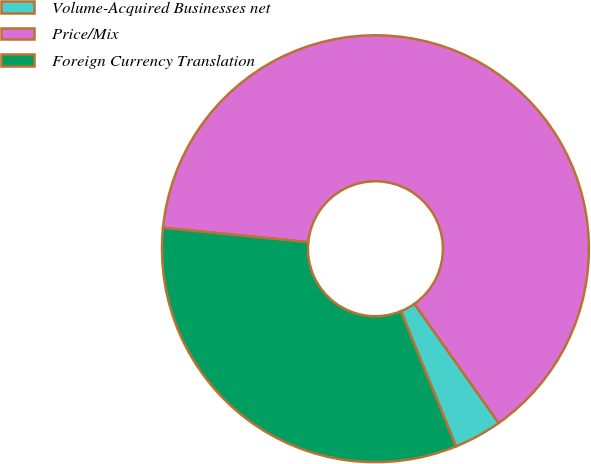Convert chart. <chart><loc_0><loc_0><loc_500><loc_500><pie_chart><fcel>Volume-Acquired Businesses net<fcel>Price/Mix<fcel>Foreign Currency Translation<nl><fcel>3.64%<fcel>63.64%<fcel>32.73%<nl></chart> 